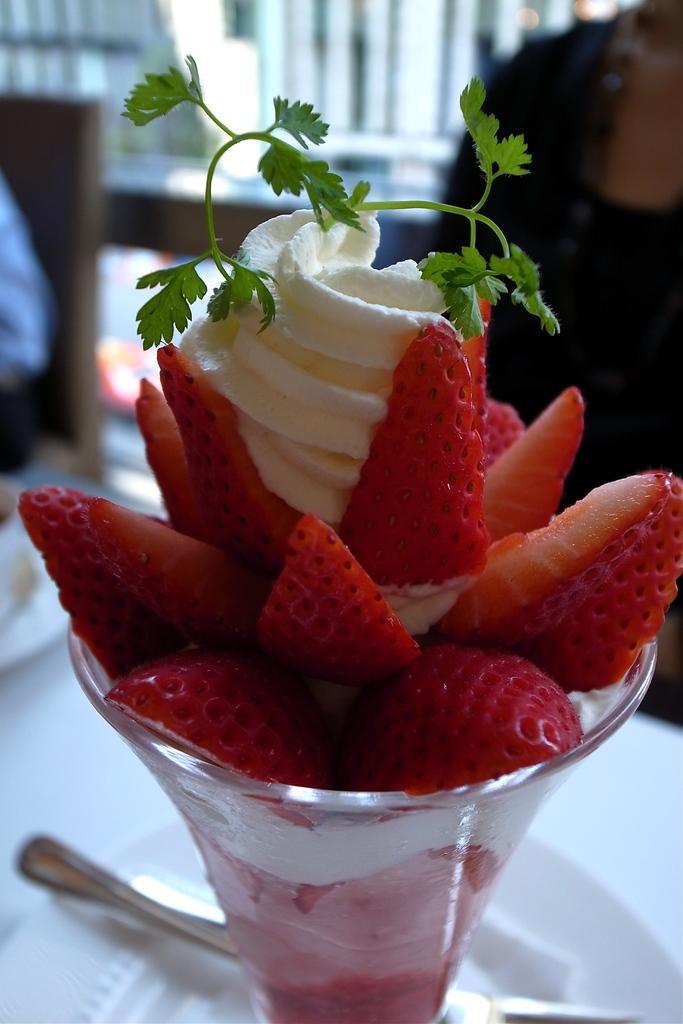Describe this image in one or two sentences. In the foreground of this image, there is an ice cream and few strawberry pieces in a glass which is on a saucer and a spoon placed on the saucer. In the background, there are two persons sitting on the chairs near a white table. In the background top side of the image, it is blurred. 